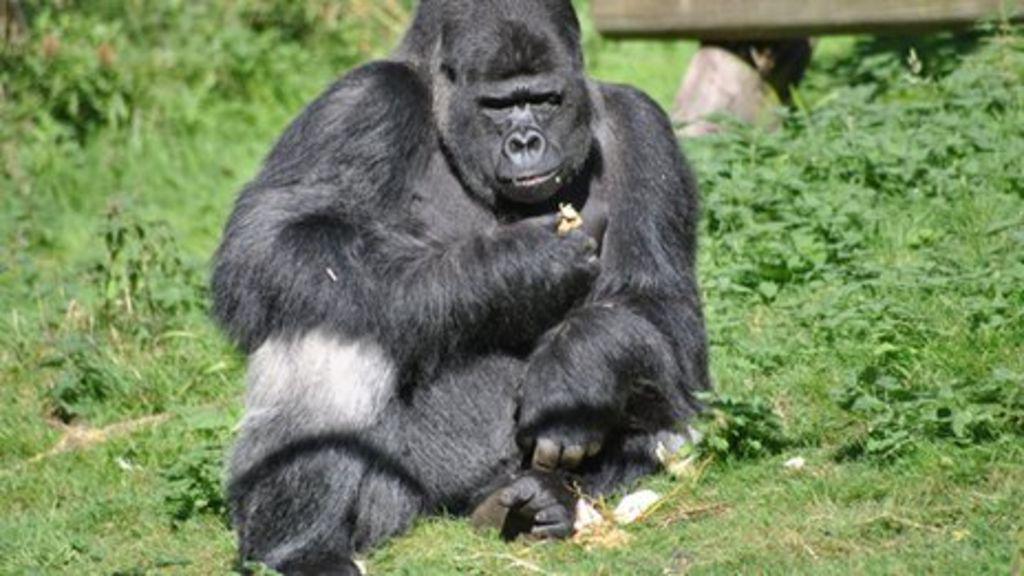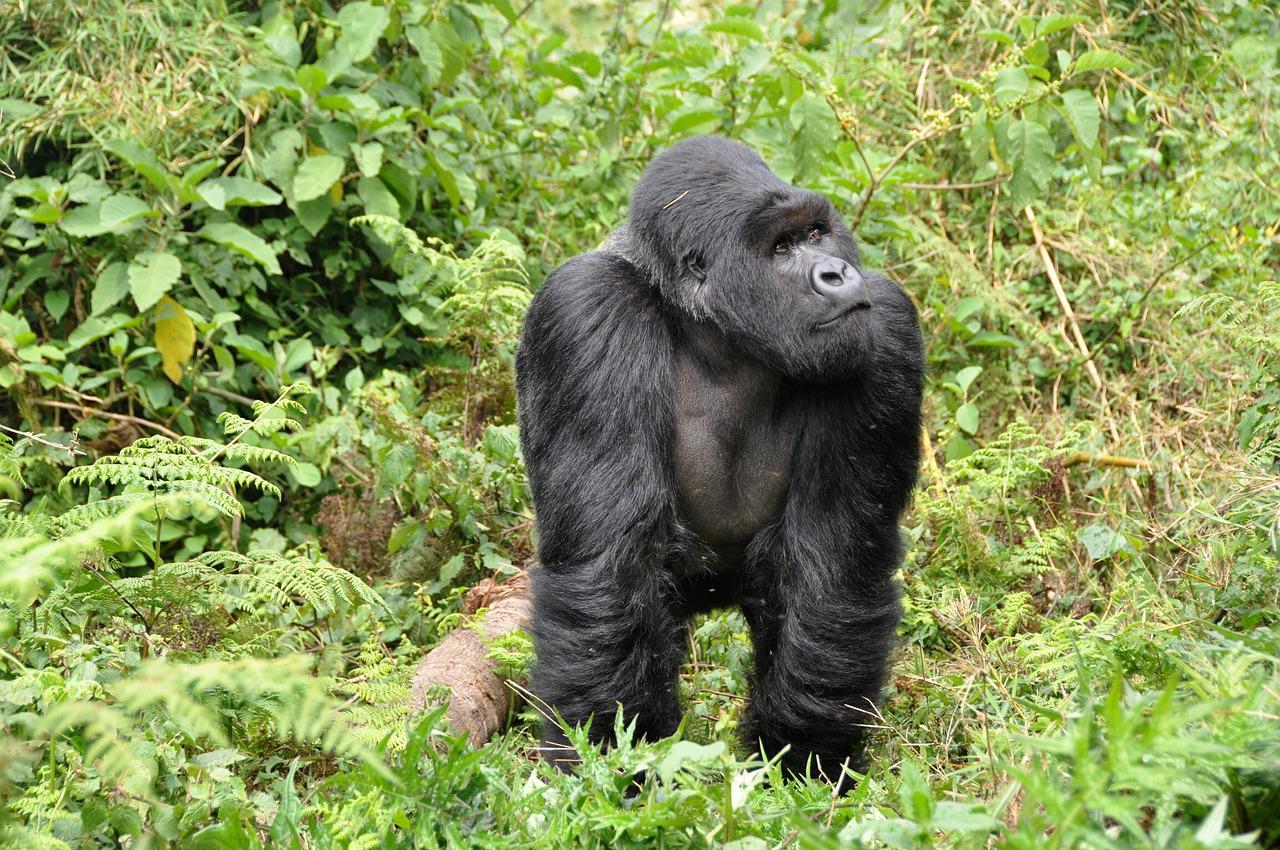The first image is the image on the left, the second image is the image on the right. For the images shown, is this caption "There is a group of gorillas in both images." true? Answer yes or no. No. The first image is the image on the left, the second image is the image on the right. Analyze the images presented: Is the assertion "The gorilla in the foreground of the right image has both its hands at mouth level, with fingers curled." valid? Answer yes or no. No. 